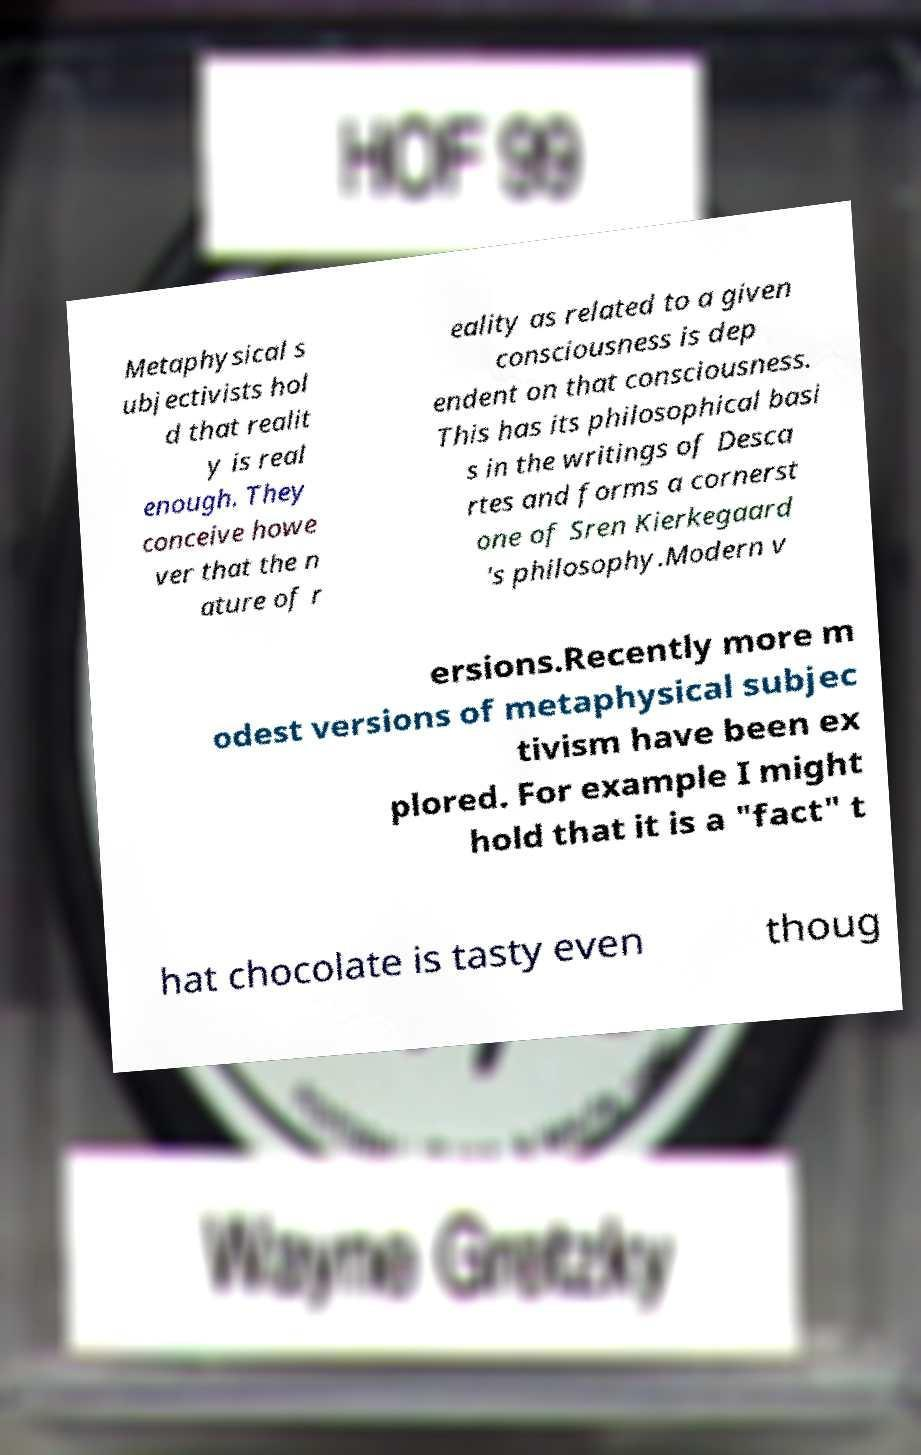Can you read and provide the text displayed in the image?This photo seems to have some interesting text. Can you extract and type it out for me? Metaphysical s ubjectivists hol d that realit y is real enough. They conceive howe ver that the n ature of r eality as related to a given consciousness is dep endent on that consciousness. This has its philosophical basi s in the writings of Desca rtes and forms a cornerst one of Sren Kierkegaard 's philosophy.Modern v ersions.Recently more m odest versions of metaphysical subjec tivism have been ex plored. For example I might hold that it is a "fact" t hat chocolate is tasty even thoug 